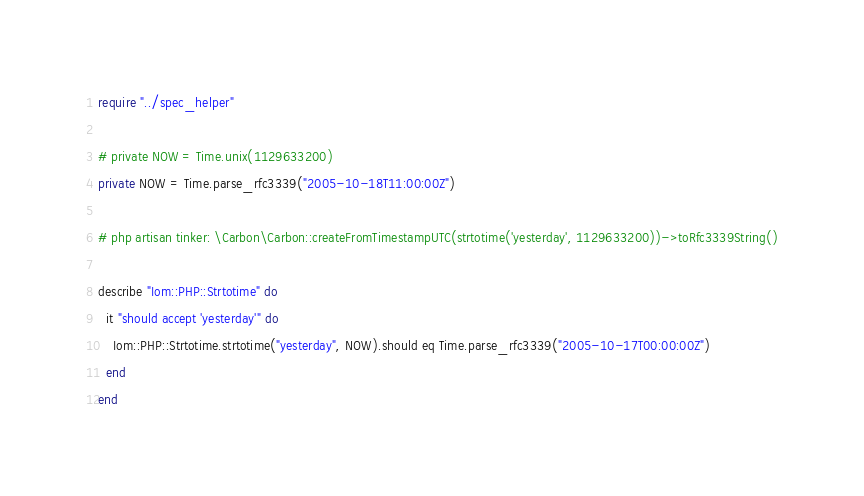Convert code to text. <code><loc_0><loc_0><loc_500><loc_500><_Crystal_>require "../spec_helper"

# private NOW = Time.unix(1129633200)
private NOW = Time.parse_rfc3339("2005-10-18T11:00:00Z")

# php artisan tinker: \Carbon\Carbon::createFromTimestampUTC(strtotime('yesterday', 1129633200))->toRfc3339String()

describe "Iom::PHP::Strtotime" do
  it "should accept 'yesterday'" do
    Iom::PHP::Strtotime.strtotime("yesterday", NOW).should eq Time.parse_rfc3339("2005-10-17T00:00:00Z")
  end
end
</code> 